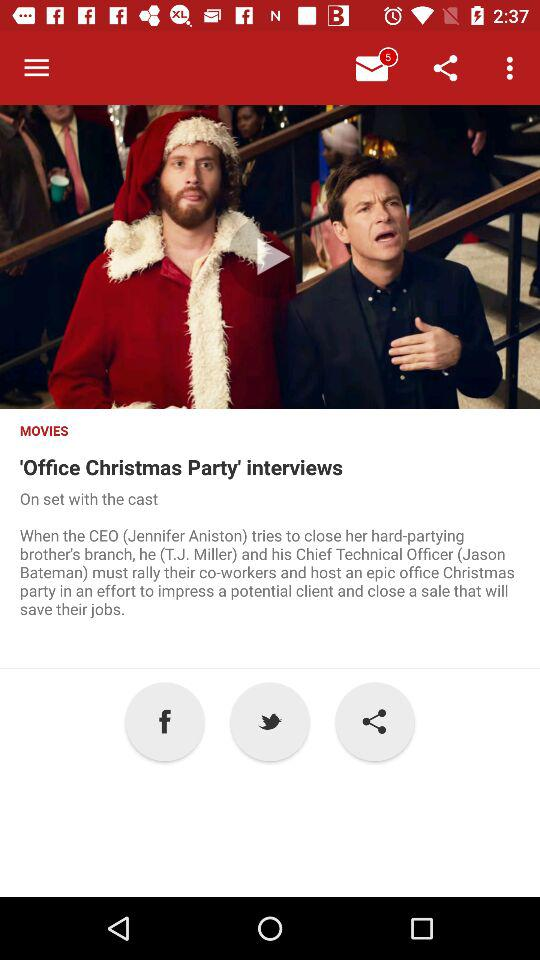What's the number of unread alert notifications on the "Message" icon? The number of unread alert notifications on the "Message" icon is 5. 